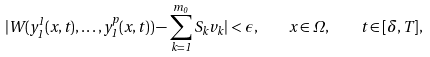Convert formula to latex. <formula><loc_0><loc_0><loc_500><loc_500>| W ( y _ { 1 } ^ { 1 } ( x , t ) , \dots , y _ { 1 } ^ { p } ( x , t ) ) - \sum _ { k = 1 } ^ { m _ { 0 } } S _ { k } v _ { k } | < \epsilon , \quad x \in \Omega , \quad t \in [ \delta , T ] ,</formula> 